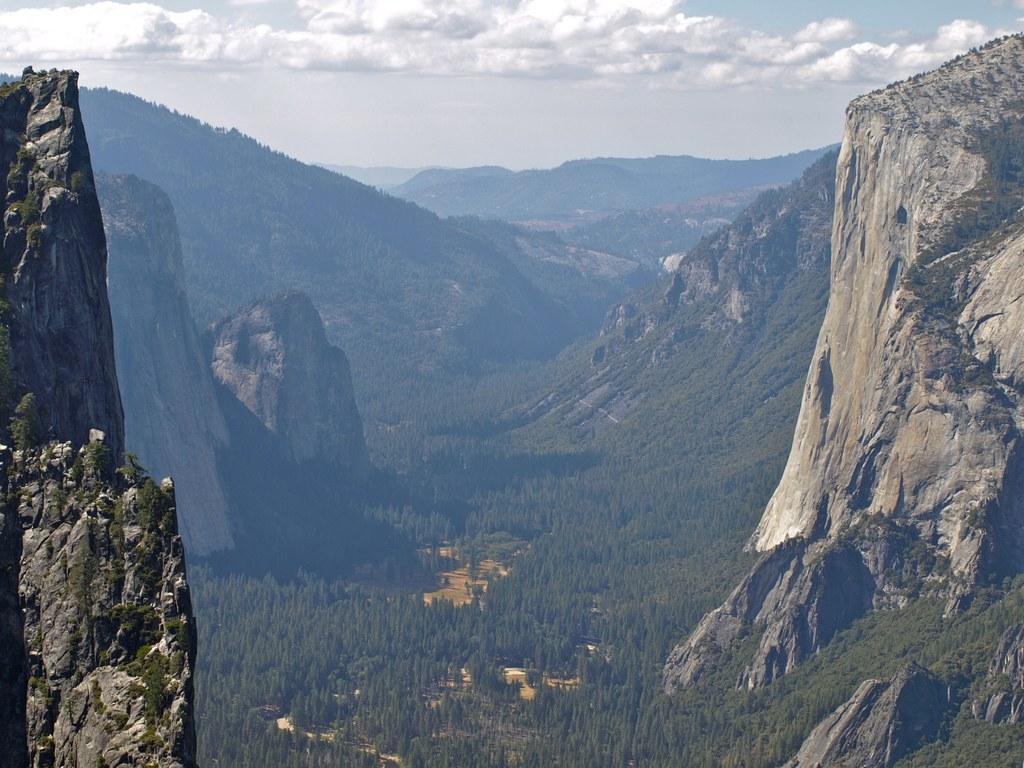Please provide a concise description of this image. In this image, we can see rocks, hills and trees. Top of the image, there is a cloudy sky. 